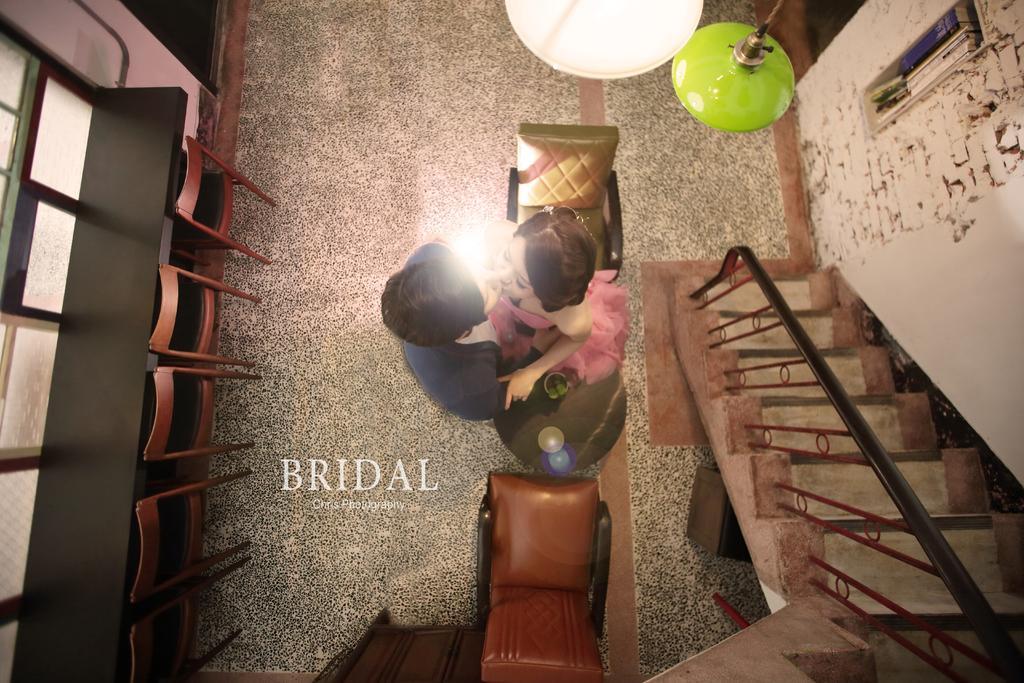Describe this image in one or two sentences. This is the picture taken in a room, there are two persons standing on the floor. On the floor there are chairs and table and staircase. On top of them there are lights. 